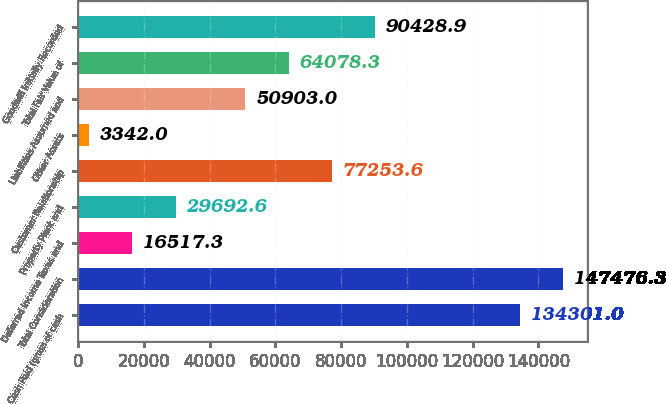Convert chart. <chart><loc_0><loc_0><loc_500><loc_500><bar_chart><fcel>Cash Paid (gross of cash<fcel>Total Consideration<fcel>Deferred Income Taxes and<fcel>Property Plant and<fcel>Customer Relationship<fcel>Other Assets<fcel>Liabilities Assumed and<fcel>Total Fair Value of<fcel>Goodwill Initially Recorded<nl><fcel>134301<fcel>147476<fcel>16517.3<fcel>29692.6<fcel>77253.6<fcel>3342<fcel>50903<fcel>64078.3<fcel>90428.9<nl></chart> 